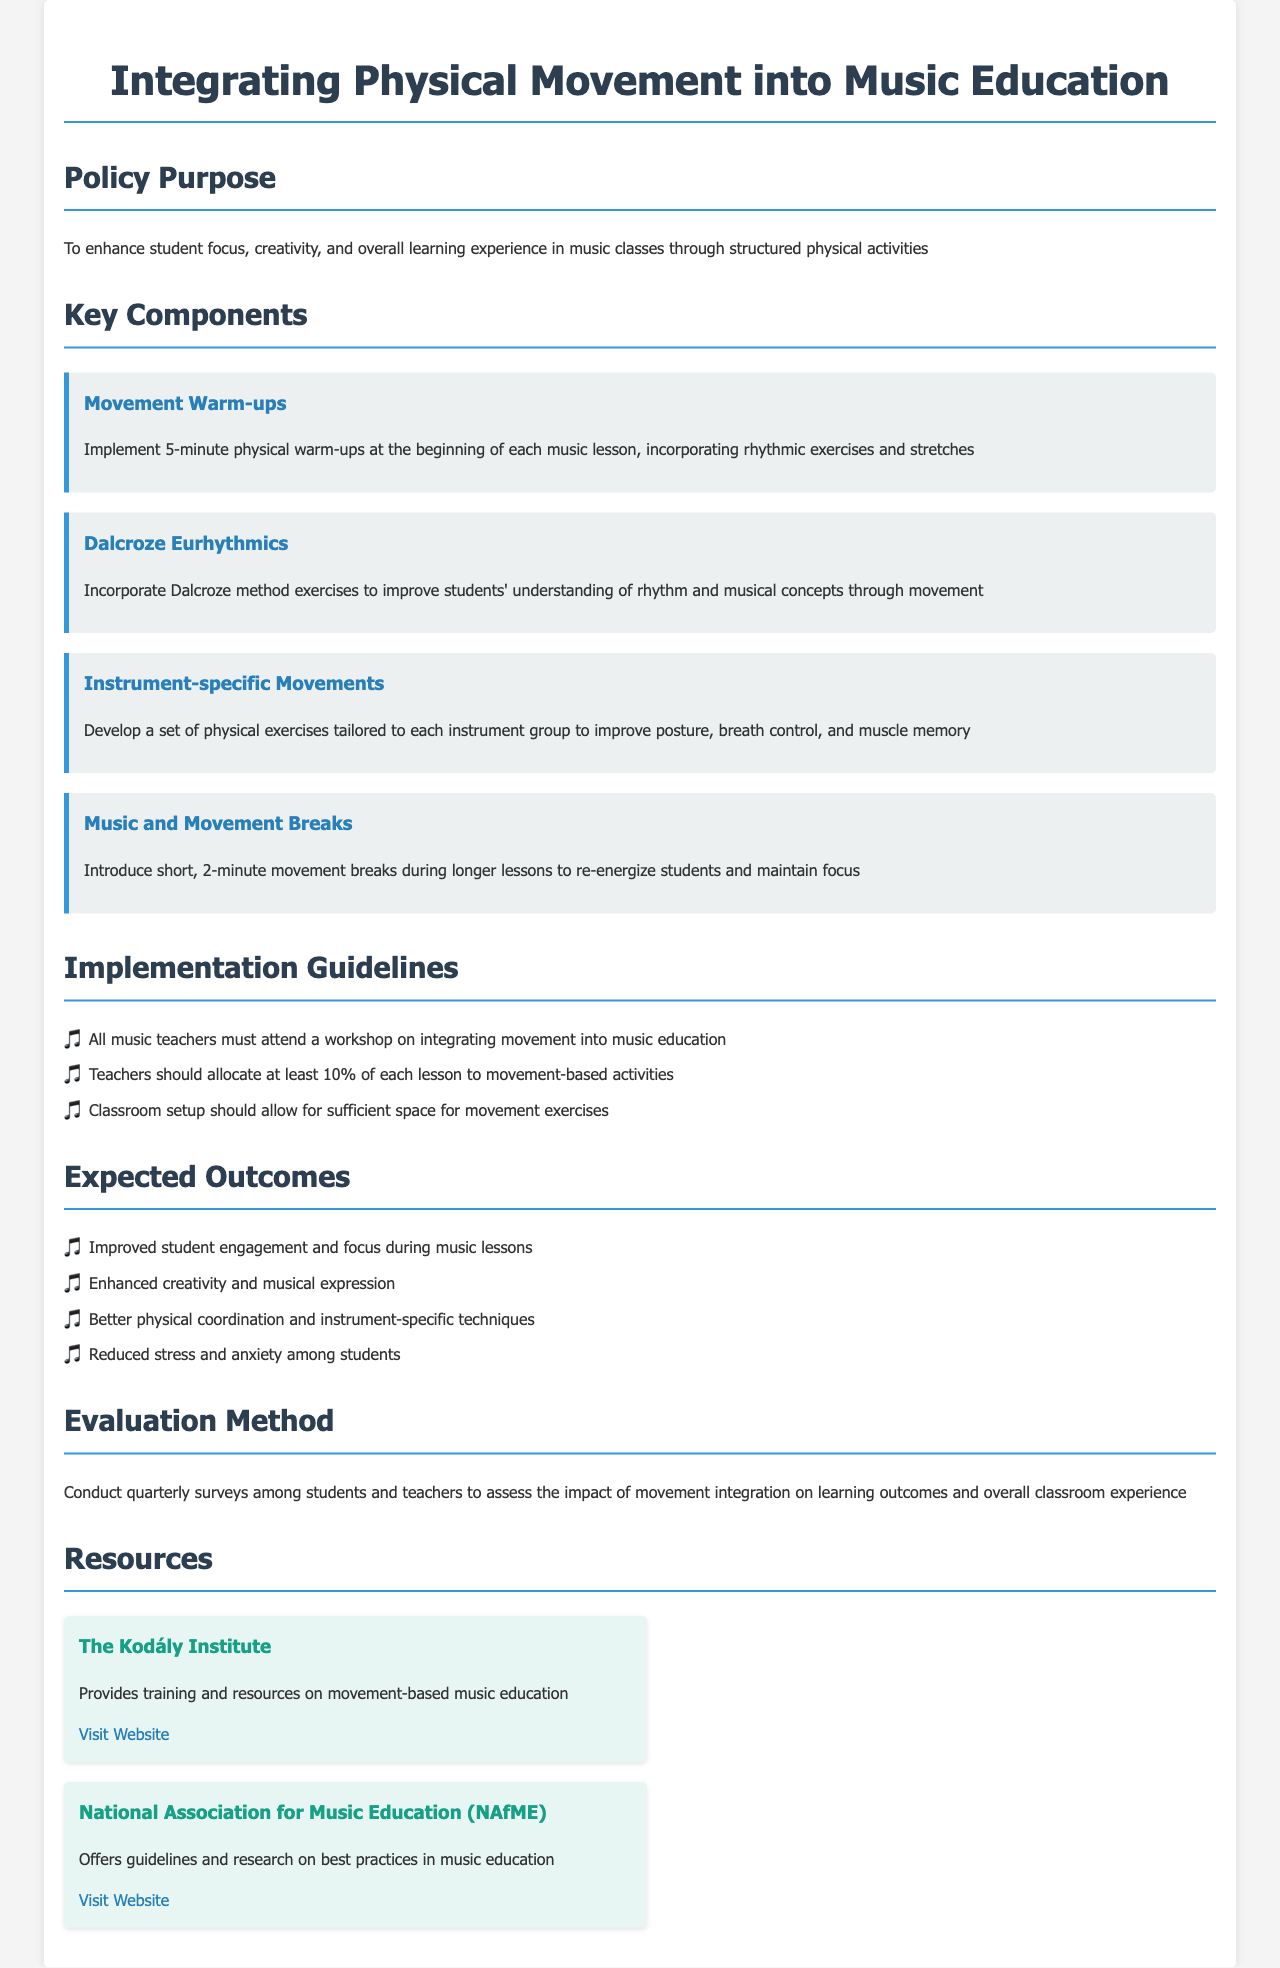What is the purpose of the policy? The purpose of the policy is to enhance student focus, creativity, and overall learning experience in music classes through structured physical activities.
Answer: To enhance student focus, creativity, and overall learning experience What is one key component mentioned in the policy? The policy outlines several key components; one example is the movement warm-ups.
Answer: Movement Warm-ups What percentage of each lesson should be allocated to movement-based activities? The document specifies at least 10% of each lesson should be allocated to movement-based activities.
Answer: 10% How often should surveys be conducted to assess the impact of movement integration? The document states that surveys should be conducted quarterly.
Answer: Quarterly What is one expected outcome of integrating physical movement into music lessons? The document lists multiple expected outcomes; an example is improved student engagement.
Answer: Improved student engagement What type of workshop must all music teachers attend? The document specifies a workshop on integrating movement into music education.
Answer: Workshop on integrating movement How long should movement breaks be during longer lessons? The policy indicates that the movement breaks should be 2 minutes.
Answer: 2 minutes What method is suggested for improving understanding of rhythm? The document refers to the Dalcroze method for improving rhythm understanding through movement.
Answer: Dalcroze method What organization provides training and resources on movement-based music education? The Kodály Institute is mentioned as providing training and resources.
Answer: The Kodály Institute What does the implementation guideline suggest regarding classroom setup? The guideline states that classroom setup should allow for sufficient space for movement exercises.
Answer: Sufficient space for movement exercises 